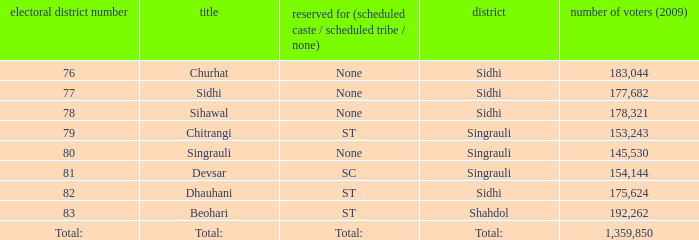What is the district with 79 constituency number? Singrauli. 